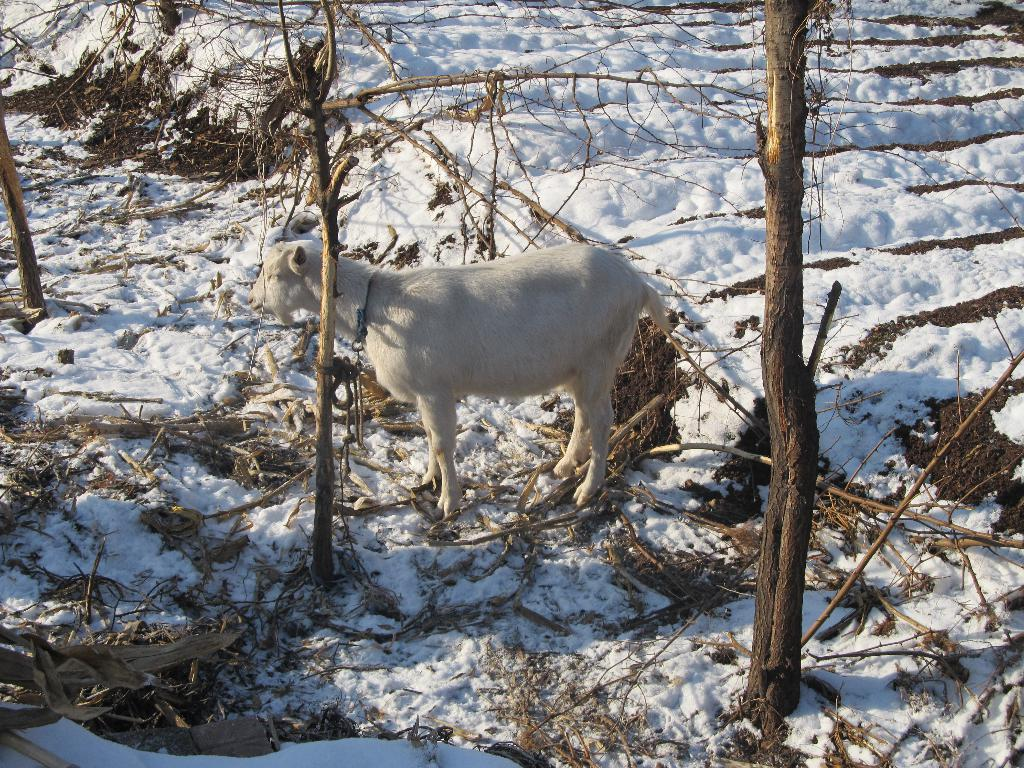What animal is present in the image? There is a goat in the image. What is the goat doing in the image? The goat is standing in the image. What is the color of the goat? The goat is white in color. What type of vegetation can be seen in the image? There are trees in the image. What is covering the ground in the image? Dried leaves are lying on the snow in the image. How many times does the goat sneeze in the image? The goat does not sneeze in the image; it is simply standing. What type of whip is being used to control the goat in the image? There is no whip present in the image, and the goat is not being controlled by any external force. 